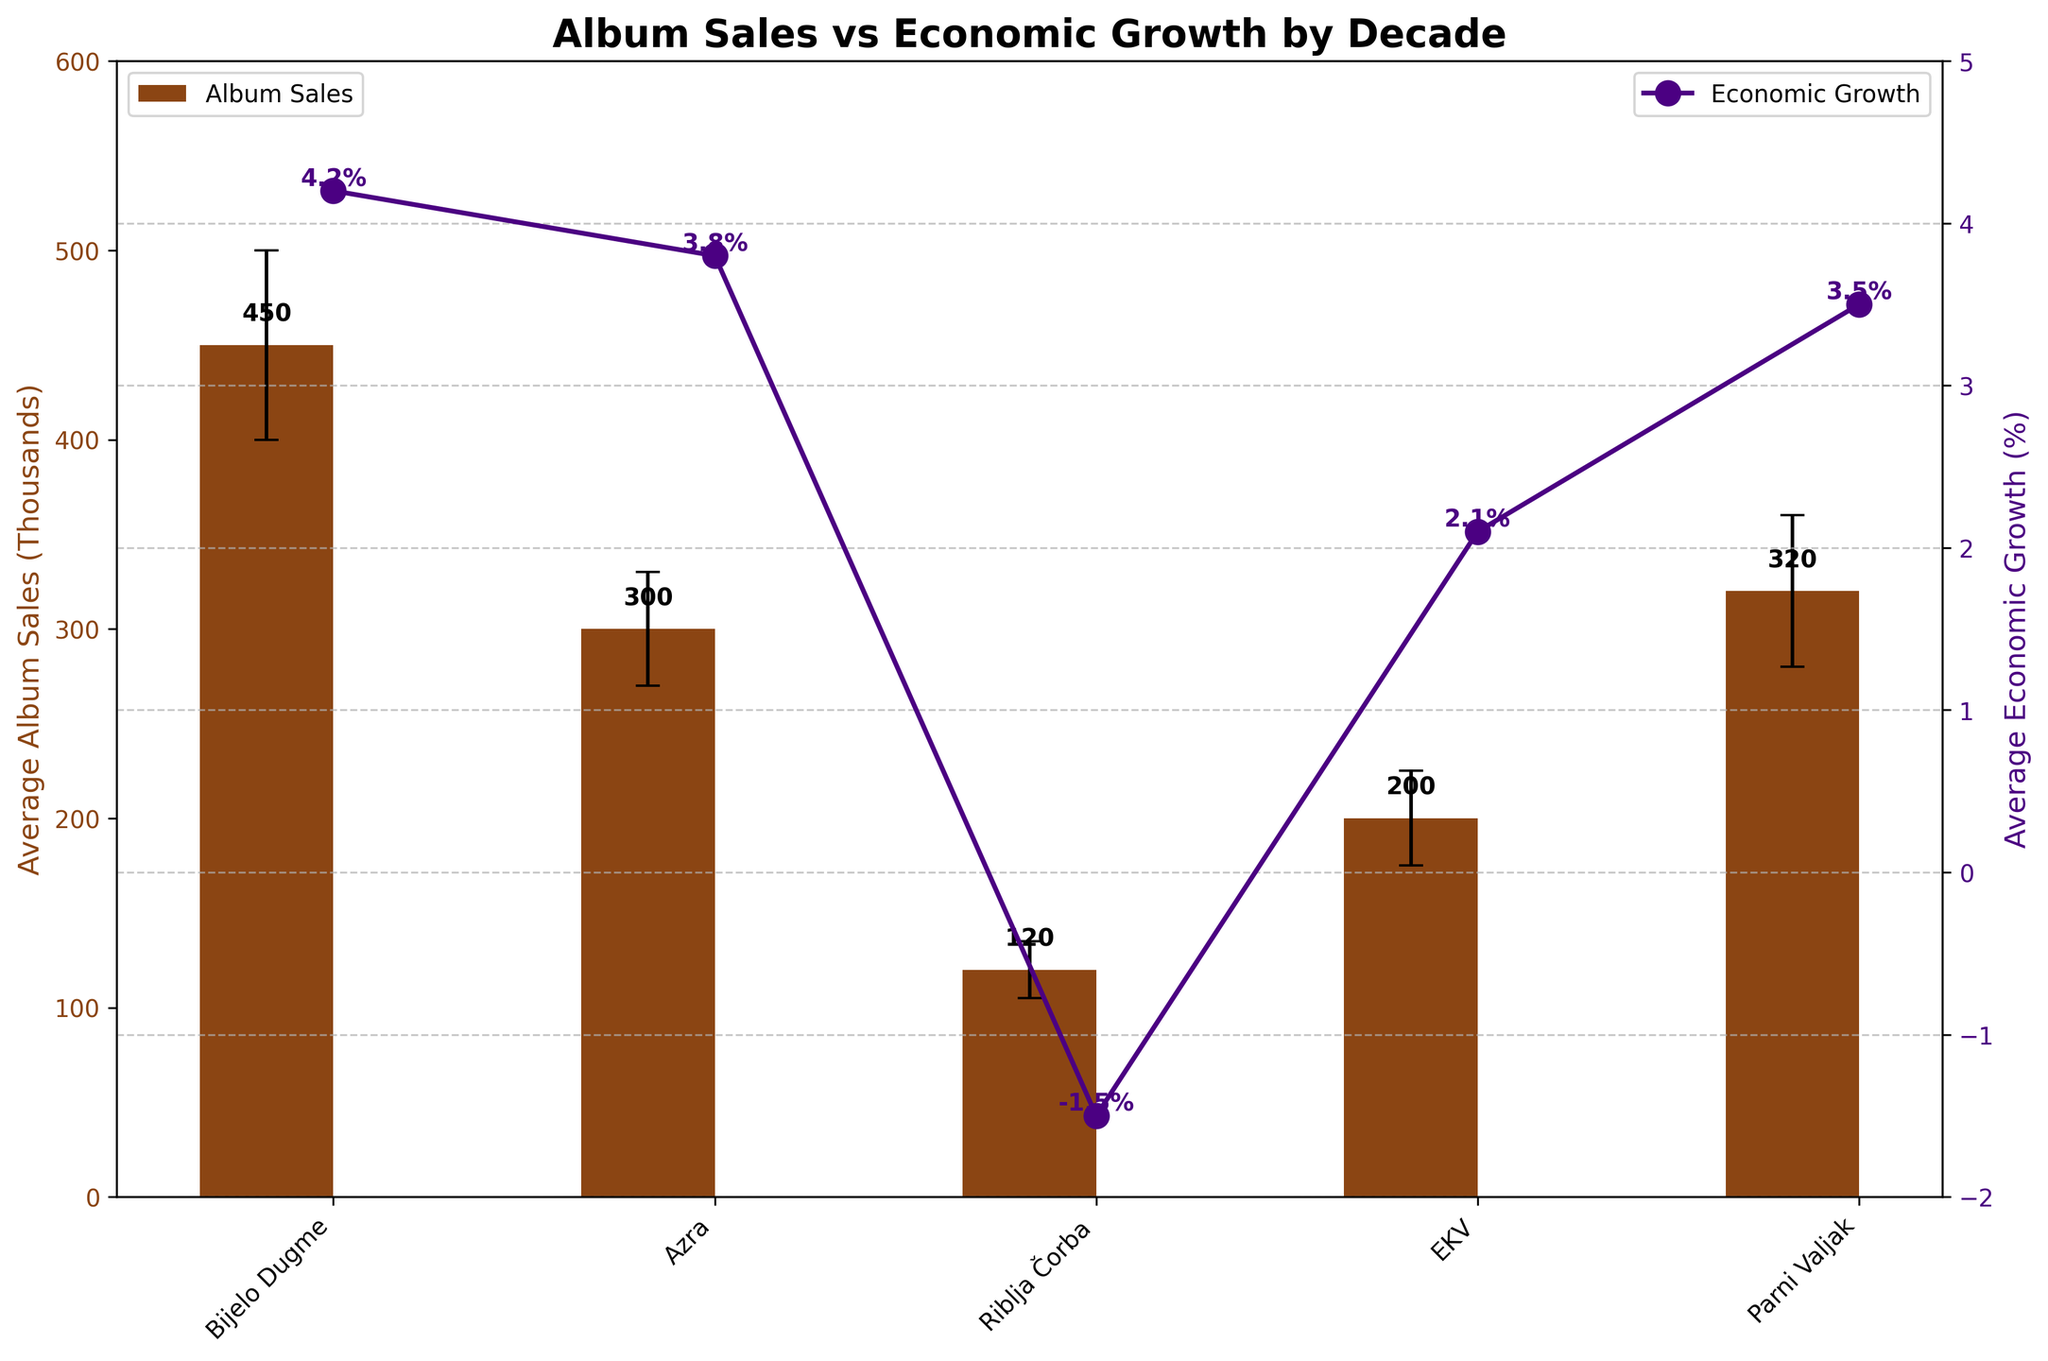How many bands are displayed in the chart? The x-axis labels indicate the bands, and there are five of them: Bijelo Dugme, Azra, Riblja Čorba, EKV, and Parni Valjak.
Answer: 5 Which band had the highest average album sales in thousands? By looking at the height of the bars, Bijelo Dugme in the 1970s had the highest average album sales at 450 thousand.
Answer: Bijelo Dugme What is the error margin for Riblja Čorba's album sales? The error bars show the uncertainty in the data, and for Riblja Čorba in the 1990s, the error margin is 15 thousand.
Answer: 15 Which decade experienced negative average economic growth? The line chart with dots shows the economic growth percentage by decade. The 1990s (Riblja Čorba) had an average economic growth of -1.5%, indicating negative growth.
Answer: 1990s Compare the average album sales of Parni Valjak in the 2010s to Azra in the 1980s. Parni Valjak had average album sales of 320 thousand in the 2010s, while Azra had 300 thousand in the 1980s. Thus, Parni Valjak's sales were higher by 20 thousand.
Answer: Parni Valjak's sales were 20 thousand higher Which band had the lowest average album sales, and what was the corresponding economic growth? The band with the lowest bar is Riblja Čorba with 120 thousand average album sales in the 1990s, and the corresponding economic growth was -1.5%.
Answer: Riblja Čorba with -1.5% What is the difference between the highest average album sales and the lowest average album sales? The highest average album sales are from Bijelo Dugme (450 thousand) and the lowest from Riblja Čorba (120 thousand). The difference is 450 - 120 = 330 thousand.
Answer: 330 thousand How does the economic growth trend appear from the 1970s to the 2010s? The economic growth percentages are plotted as a line: 4.2% in the 1970s, 3.8% in the 1980s, -1.5% in the 1990s, 2.1% in the 2000s, and 3.5% in the 2010s. It fluctuates, dropping to negative in the 1990s but generally positive in other decades.
Answer: Fluctuating, with a drop in the 1990s Which two bands had the closest average album sales, and what are their sales values? Azra with 300 thousand and Parni Valjak with 320 thousand have the closest average album sales values, differing by only 20 thousand.
Answer: Azra (300) and Parni Valjak (320) What color is used to represent the average economic growth line? The line representing average economic growth is colored in purple (indigo).
Answer: Purple 